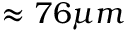Convert formula to latex. <formula><loc_0><loc_0><loc_500><loc_500>\approx 7 6 \mu m</formula> 